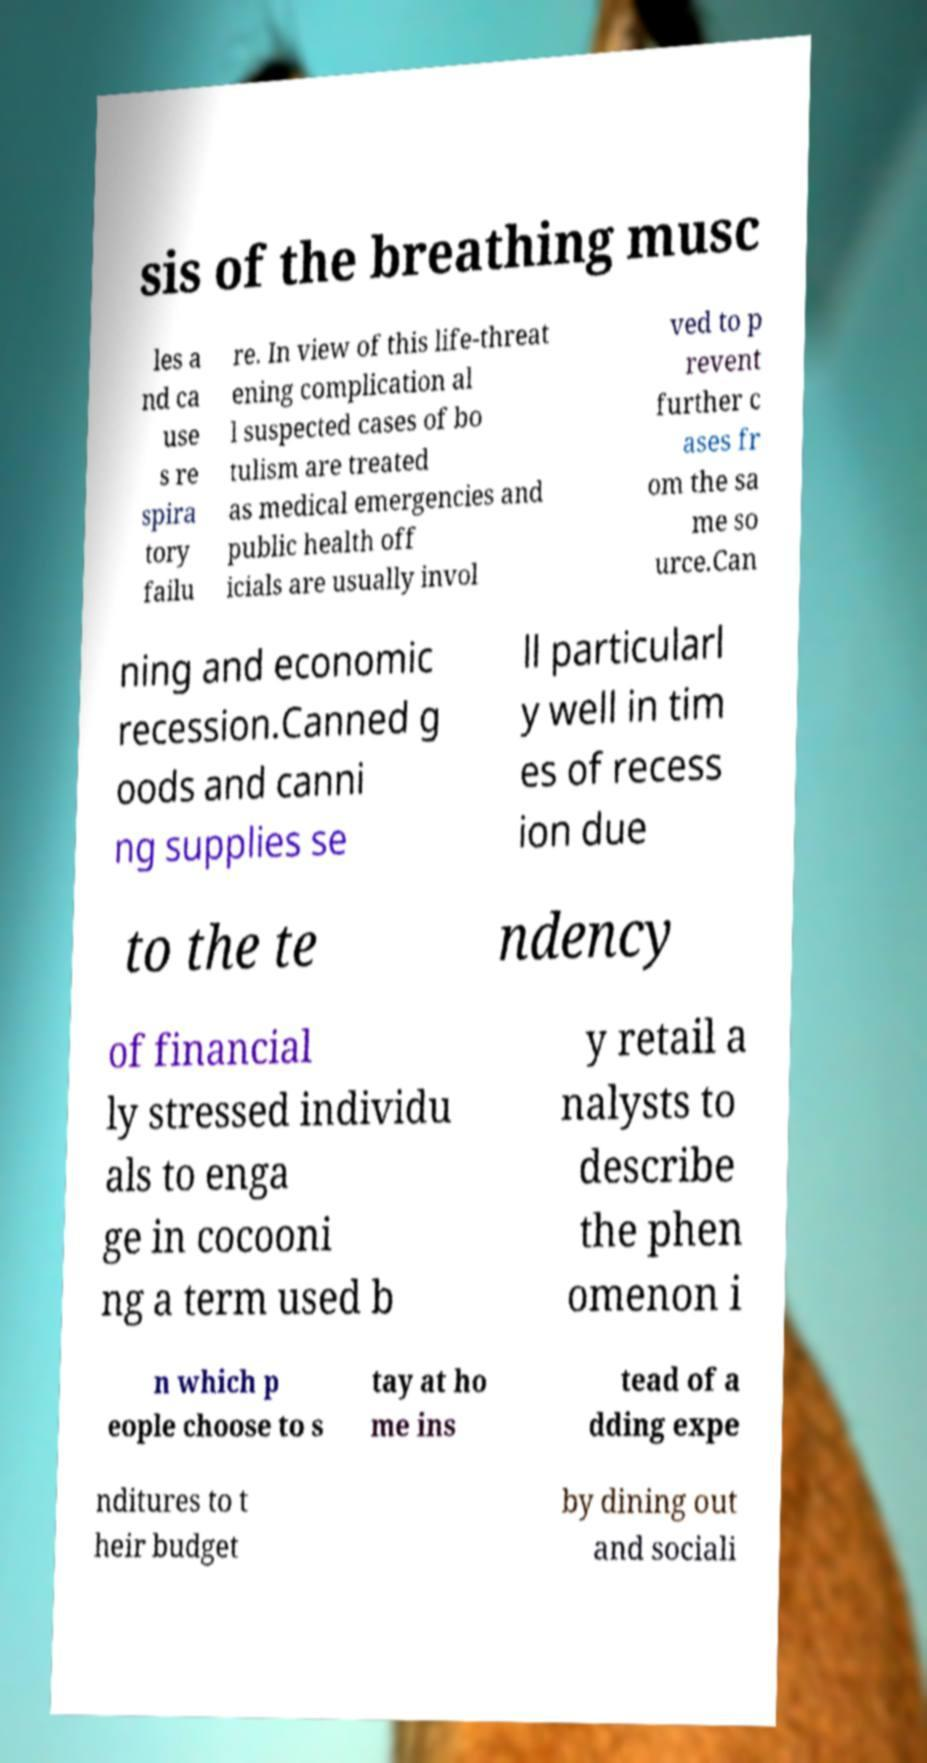What messages or text are displayed in this image? I need them in a readable, typed format. sis of the breathing musc les a nd ca use s re spira tory failu re. In view of this life-threat ening complication al l suspected cases of bo tulism are treated as medical emergencies and public health off icials are usually invol ved to p revent further c ases fr om the sa me so urce.Can ning and economic recession.Canned g oods and canni ng supplies se ll particularl y well in tim es of recess ion due to the te ndency of financial ly stressed individu als to enga ge in cocooni ng a term used b y retail a nalysts to describe the phen omenon i n which p eople choose to s tay at ho me ins tead of a dding expe nditures to t heir budget by dining out and sociali 